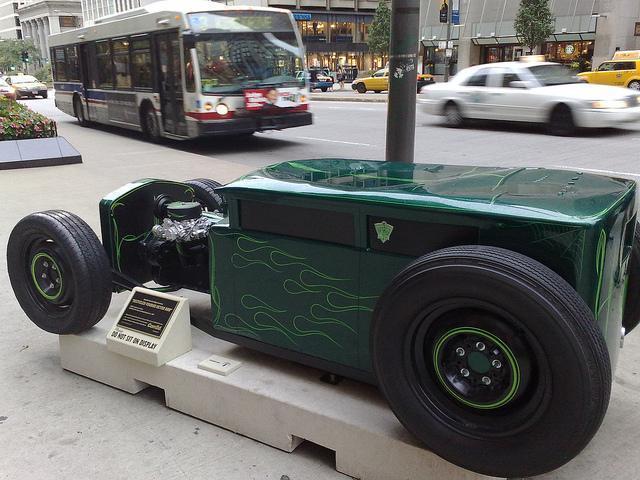Why is the car on the sidewalk?
Indicate the correct response and explain using: 'Answer: answer
Rationale: rationale.'
Options: Parking zone, accident, broke down, display. Answer: display.
Rationale: This vehicle is not functional and there is a plaque explaining itself so it would be considered a decoration. 